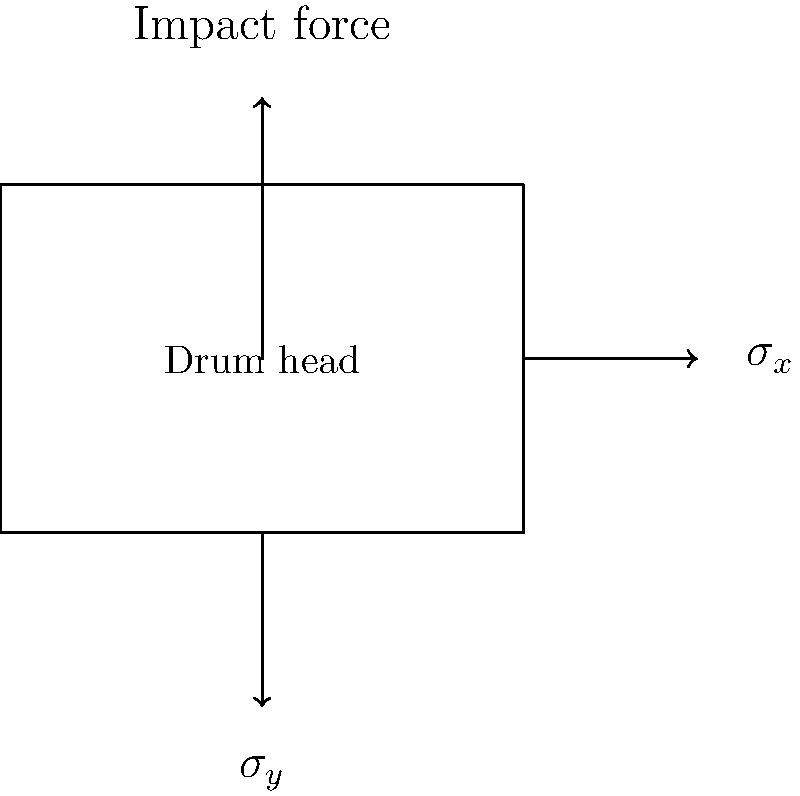As a musician, you're curious about the physics behind your instrument. Consider a circular drum head with radius $R$ and thickness $t$, subjected to an impact force $F$ at its center. If the material of the drum head has a Young's modulus $E$ and Poisson's ratio $\nu$, derive an expression for the maximum stress $\sigma_{max}$ experienced by the drum head during impact. Assume the drum head behaves like a thin plate under small deflections. Let's approach this step-by-step:

1) For a circular plate under central load, the maximum stress occurs at the center and is given by:

   $$\sigma_{max} = \frac{3F}{2\pi t^2} \left(1 + \nu\right)$$

   Where $F$ is the impact force, $t$ is the thickness, and $\nu$ is Poisson's ratio.

2) However, this formula assumes a static load. For impact, we need to consider the dynamic nature of the force. We can use the concept of impact factor $K$:

   $$K = 1 + \sqrt{1 + \frac{2h}{y_{st}}}$$

   Where $h$ is the drop height of the impacting object and $y_{st}$ is the static deflection.

3) The static deflection for a circular plate under central load is:

   $$y_{st} = \frac{3FR^2(1-\nu^2)}{4\pi Et^3}$$

   Where $E$ is Young's modulus and $R$ is the radius of the drum head.

4) Substituting this into the impact factor equation:

   $$K = 1 + \sqrt{1 + \frac{8\pi Eth}{3FR^2(1-\nu^2)}}$$

5) The maximum dynamic stress is then:

   $$\sigma_{max,dynamic} = K \cdot \sigma_{max,static}$$

6) Substituting and simplifying:

   $$\sigma_{max,dynamic} = \frac{3F}{2\pi t^2}(1+\nu) \left(1 + \sqrt{1 + \frac{8\pi Eth}{3FR^2(1-\nu^2)}}\right)$$

This is the expression for the maximum stress experienced by the drum head during impact.
Answer: $$\sigma_{max,dynamic} = \frac{3F}{2\pi t^2}(1+\nu) \left(1 + \sqrt{1 + \frac{8\pi Eth}{3FR^2(1-\nu^2)}}\right)$$ 